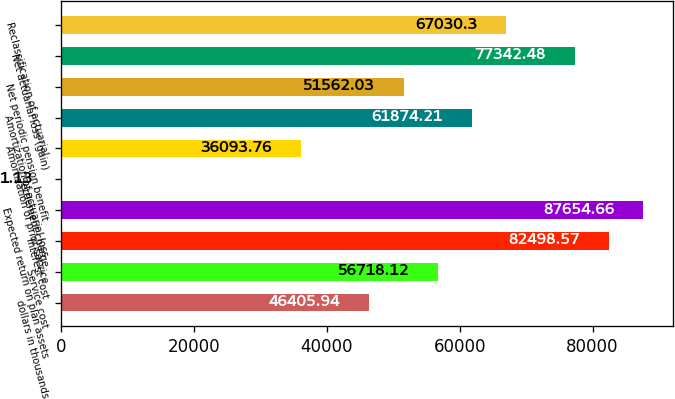Convert chart to OTSL. <chart><loc_0><loc_0><loc_500><loc_500><bar_chart><fcel>dollars in thousands<fcel>Service cost<fcel>Interest cost<fcel>Expected return on plan assets<fcel>Settlement charge<fcel>Amortization of prior service<fcel>Amortization of actuarial loss<fcel>Net periodic pension benefit<fcel>Net actuarial loss (gain)<fcel>Reclassification of actuarial<nl><fcel>46405.9<fcel>56718.1<fcel>82498.6<fcel>87654.7<fcel>1.13<fcel>36093.8<fcel>61874.2<fcel>51562<fcel>77342.5<fcel>67030.3<nl></chart> 